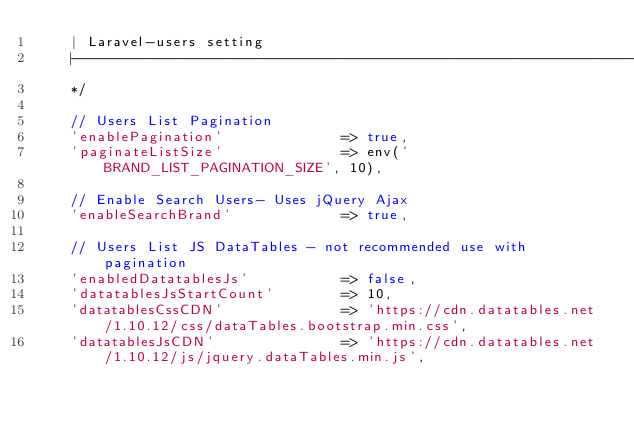<code> <loc_0><loc_0><loc_500><loc_500><_PHP_>    | Laravel-users setting
    |--------------------------------------------------------------------------
    */

    // Users List Pagination
    'enablePagination'              => true,
    'paginateListSize'              => env('BRAND_LIST_PAGINATION_SIZE', 10),

    // Enable Search Users- Uses jQuery Ajax
    'enableSearchBrand'             => true,

    // Users List JS DataTables - not recommended use with pagination
    'enabledDatatablesJs'           => false,
    'datatablesJsStartCount'        => 10,
    'datatablesCssCDN'              => 'https://cdn.datatables.net/1.10.12/css/dataTables.bootstrap.min.css',
    'datatablesJsCDN'               => 'https://cdn.datatables.net/1.10.12/js/jquery.dataTables.min.js',</code> 